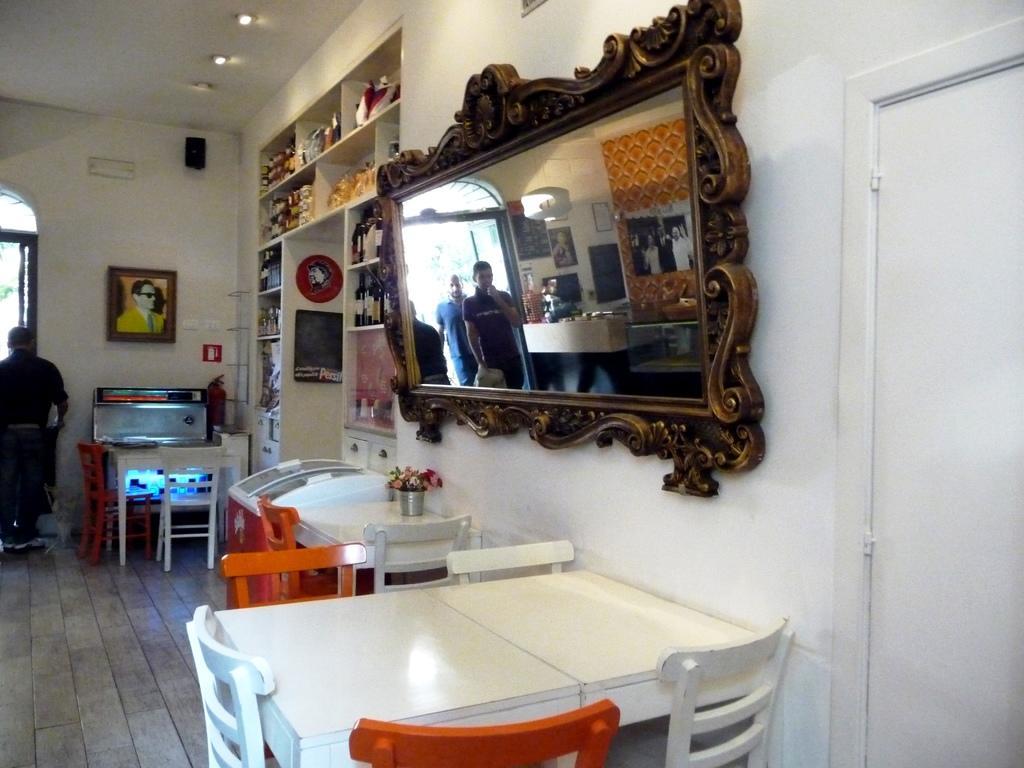Could you give a brief overview of what you see in this image? In this picture we can see chairs and table, on the left side there is a person standing, on the right side there is a mirror, there is a reflection of two persons in the mirror, in the background there is a wall, we can see a photo frame on the wall, on the right side we can see shelves, there are some things present on the shelves, we can see lights at the top of the picture. 